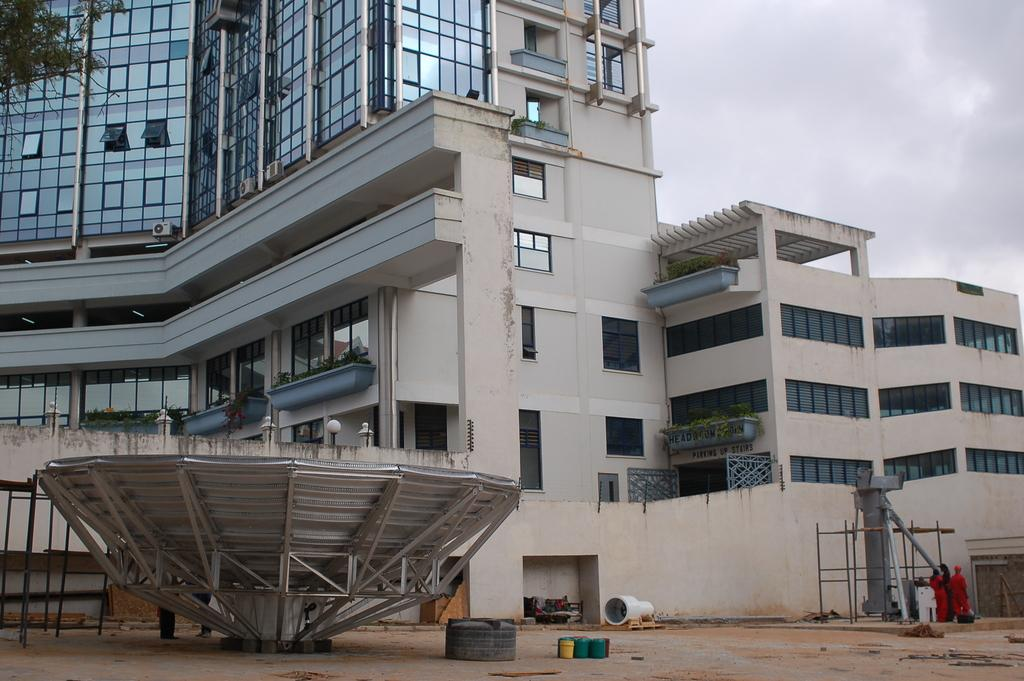What type of building is in the middle of the image? There is a big building with glass in the image. Where is the building located in the image? The building is in the middle of the image. What are the men wearing on the right side of the image? The men are wearing orange color dresses on the right side of the image. How would you describe the sky in the image? The sky is cloudy in the image. What type of jewel is being distributed for peace in the image? There is no jewel or distribution for peace present in the image. 